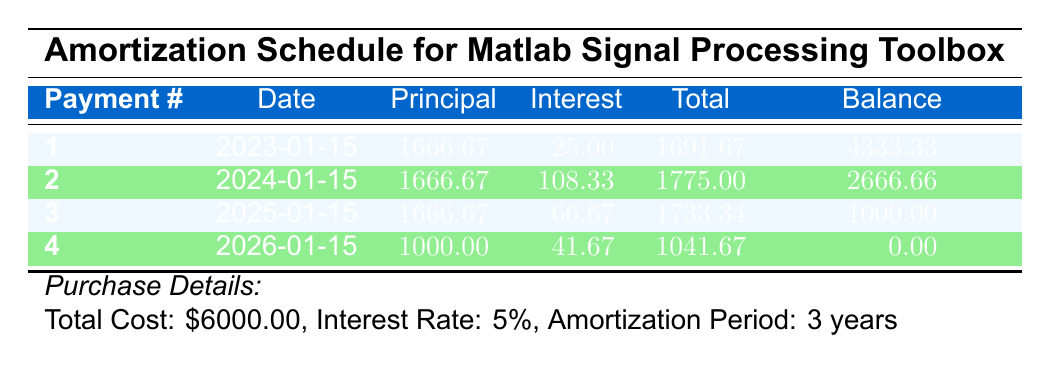What is the total cost of the software licenses? The total cost is explicitly listed in the purchase details section of the table as $6000.00.
Answer: $6000.00 How much interest was paid in the first payment? The interest payment for the first payment is clearly mentioned in the table as $25.00.
Answer: $25.00 What is the principal amount paid in the last payment? The principal payment for the fourth payment is shown in the table as $1000.00.
Answer: $1000.00 Is the remaining balance after the third payment zero? The remaining balance after the third payment is shown in the table as $1000.00, which is not zero.
Answer: No What was the average total payment made across all payments? To find the average total payment, sum all total payments: (1691.67 + 1775.00 + 1733.34 + 1041.67) = 6341.68. Then, divide by the number of payments (4): 6341.68 / 4 = 1585.42.
Answer: 1585.42 How much did the total interest paid increase from the first to the second payment? From the table, the interest payment for the first payment is $25.00 and for the second payment is $108.33. The increase is calculated as $108.33 - $25.00 = $83.33.
Answer: $83.33 What is the total principal paid after all four payments? By adding the principal payments from all payments: (1666.67 + 1666.67 + 1666.67 + 1000.00) = 5000.01. Hence, the total principal paid is $5000.01.
Answer: $5000.01 Was the interest rate used for amortization above 5%? The interest rate mentioned in the purchase details is 5%, so it is not above 5%.
Answer: No How many payments will it take to completely pay off the license cost? The final payment is made in the fourth payment, where the remaining balance is $0.00. Therefore, it took a total of 4 payments to pay off the license cost completely.
Answer: 4 